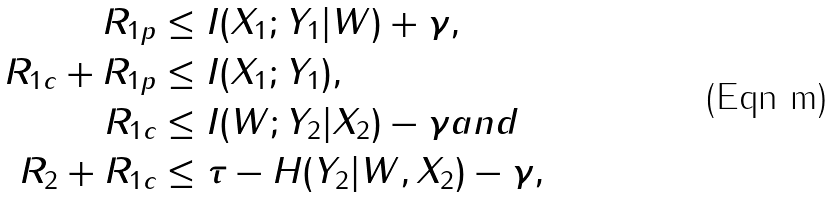<formula> <loc_0><loc_0><loc_500><loc_500>R _ { 1 p } & \leq I ( X _ { 1 } ; Y _ { 1 } | W ) + \gamma , \\ R _ { 1 c } + R _ { 1 p } & \leq I ( X _ { 1 } ; Y _ { 1 } ) , \\ R _ { 1 c } & \leq I ( W ; Y _ { 2 } | X _ { 2 } ) - \gamma a n d \\ R _ { 2 } + R _ { 1 c } & \leq \tau - H ( Y _ { 2 } | W , X _ { 2 } ) - \gamma ,</formula> 